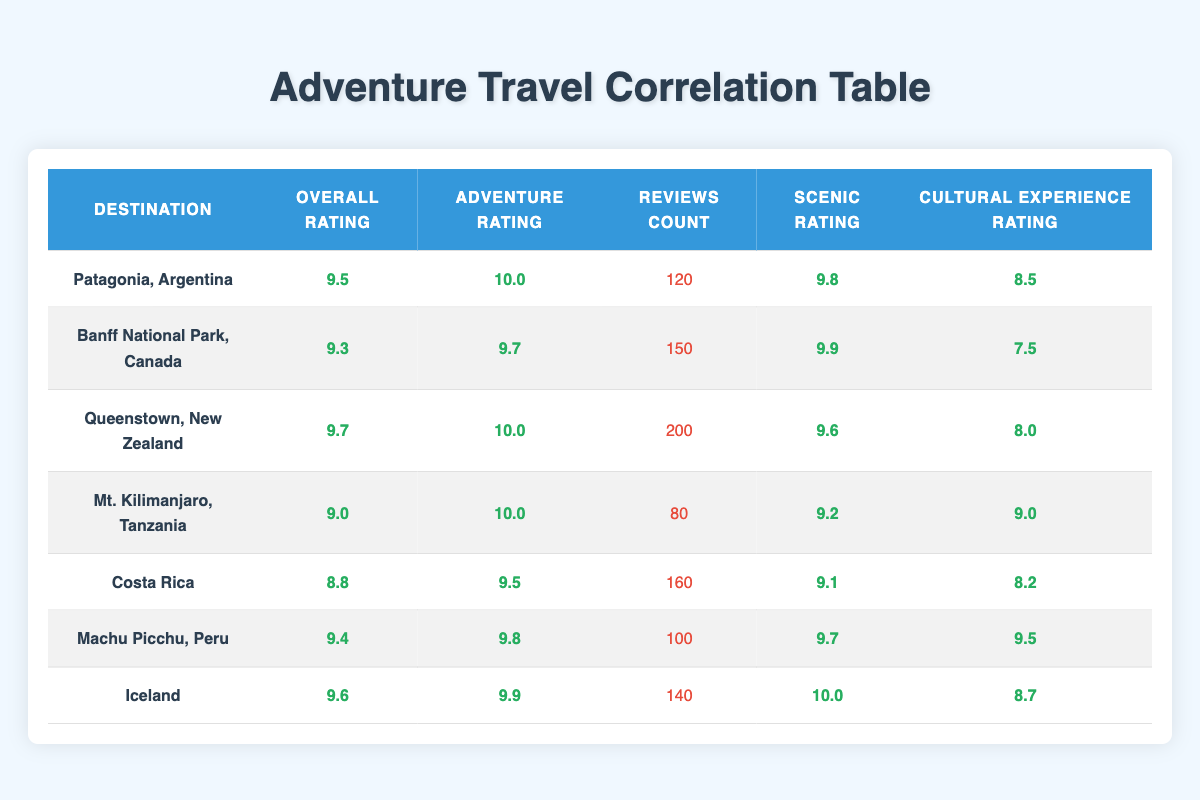What is the overall rating for Queenstown, New Zealand? Looking at the table, we find the row for Queenstown, New Zealand, where the overall rating is clearly listed as 9.7.
Answer: 9.7 Which destination has the highest adventure rating? By examining the adventure ratings in the table, both Patagonia, Argentina and Queenstown, New Zealand have an adventure rating of 10, which is the highest recorded among the locations.
Answer: Patagonia, Argentina and Queenstown, New Zealand How many reviews does Machu Picchu, Peru have? In the table, the number of reviews for Machu Picchu, Peru is specifically noted in its row as 100.
Answer: 100 What is the average scenic rating of all destinations? To calculate the average scenic rating, we sum the scenic ratings (9.8 + 9.9 + 9.6 + 9.2 + 9.1 + 9.7 + 10.0 = 67.3) and then divide by the number of destinations (7): 67.3 / 7 = 9.6142857, which can be rounded to 9.6.
Answer: 9.6 Is the overall rating for Costa Rica higher than Mt. Kilimanjaro, Tanzania? The overall rating for Costa Rica is 8.8 while Mt. Kilimanjaro has an overall rating of 9.0. Since 8.8 is not higher than 9.0, the answer is no.
Answer: No Which destination has the most reviews? By comparing the reviews count across all destinations in the table, we can see that Queenstown, New Zealand has the highest number of reviews at 200.
Answer: Queenstown, New Zealand What is the difference in overall rating between the highest-rated destination and the lowest-rated one? The highest-rated destination is Patagonia, Argentina with a rating of 9.5 and the lowest is Costa Rica at 8.8. The difference is 9.5 - 8.8 = 0.7.
Answer: 0.7 Is the cultural experience rating for Iceland above 9.0? In the table, Iceland has a cultural experience rating of 8.7, which is below 9.0. Thus, the answer is no.
Answer: No Which destination has a scenic rating lower than 9.5? Looking through the scenic ratings, Costa Rica (9.1) and Mt. Kilimanjaro (9.2) have scenic ratings lower than 9.5.
Answer: Costa Rica and Mt. Kilimanjaro 